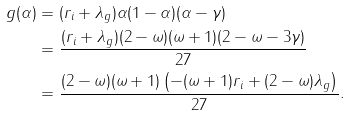<formula> <loc_0><loc_0><loc_500><loc_500>g ( \alpha ) & = ( r _ { i } + \lambda _ { g } ) \alpha ( 1 - \alpha ) ( \alpha - \gamma ) \\ & = \frac { ( r _ { i } + \lambda _ { g } ) ( 2 - \omega ) ( \omega + 1 ) ( 2 - \omega - 3 \gamma ) } { 2 7 } \\ & = \frac { ( 2 - \omega ) ( \omega + 1 ) \left ( - ( \omega + 1 ) r _ { i } + ( 2 - \omega ) \lambda _ { g } \right ) } { 2 7 } .</formula> 